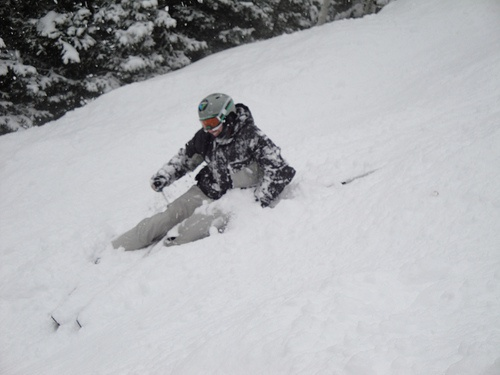Describe the objects in this image and their specific colors. I can see people in black, gray, and darkgray tones and skis in black, lightgray, and darkgray tones in this image. 